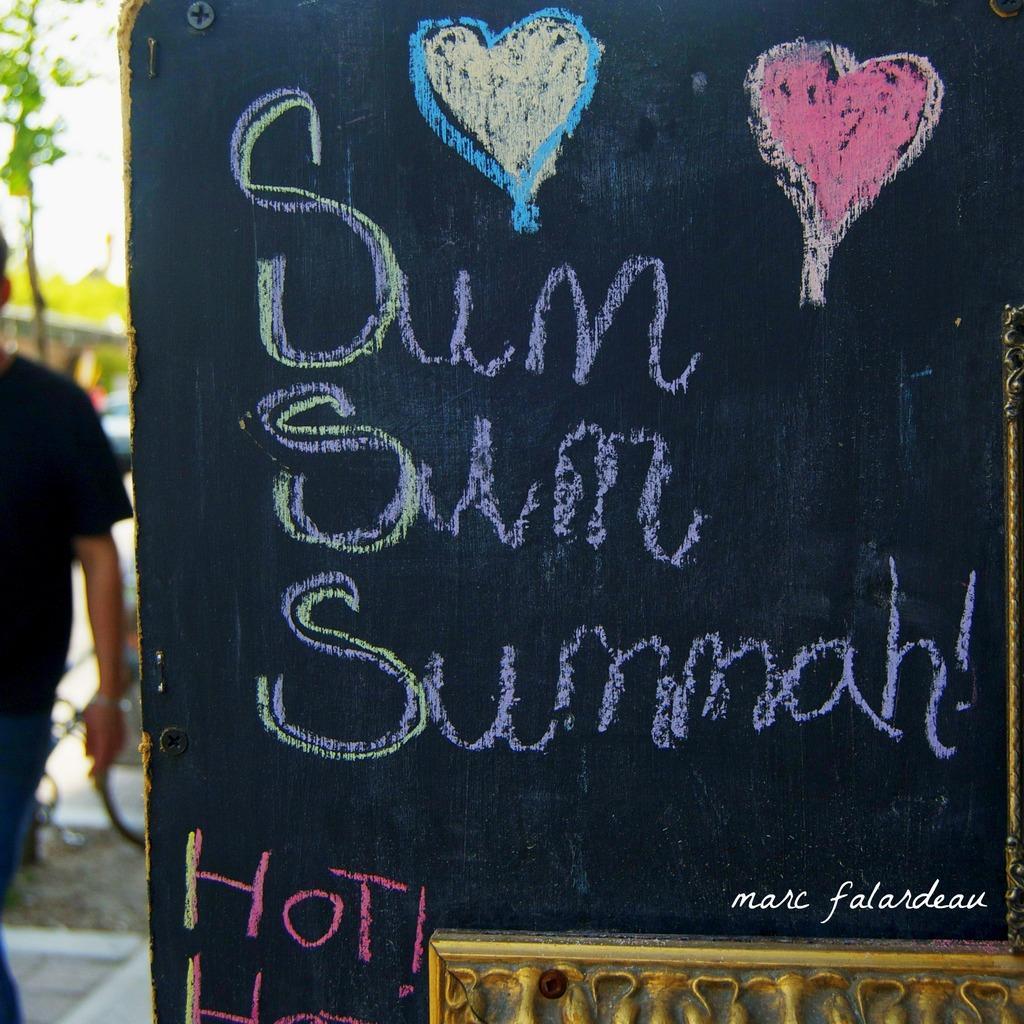Could you give a brief overview of what you see in this image? Bottom left side of the image a man is standing. Behind him there are some trees and vehicles. Bottom right side of the image there is a banner. 